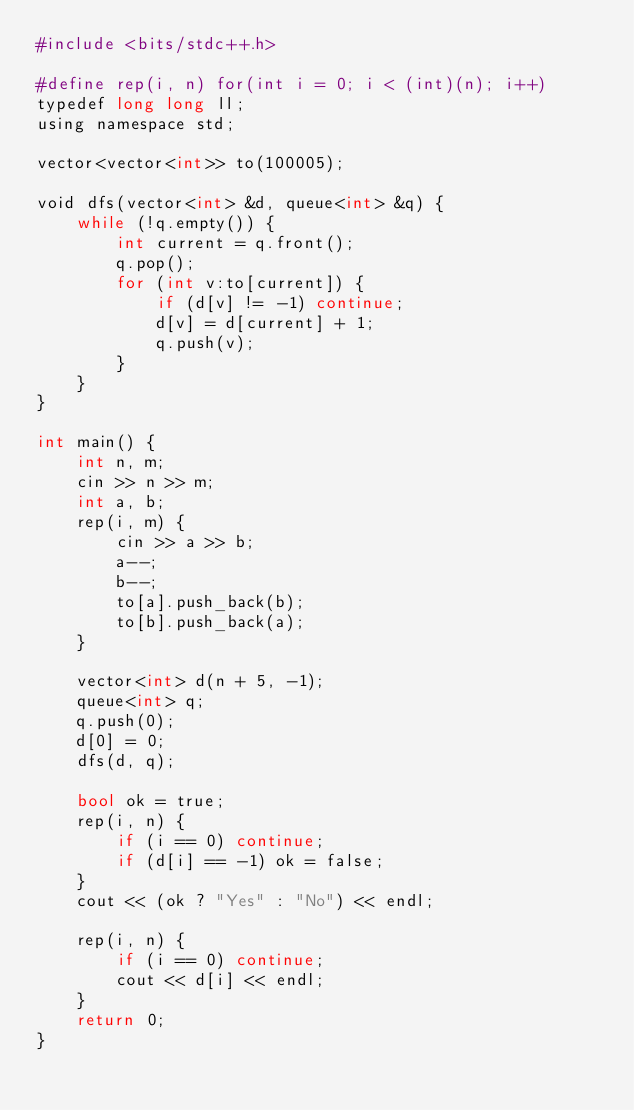Convert code to text. <code><loc_0><loc_0><loc_500><loc_500><_Python_>#include <bits/stdc++.h>

#define rep(i, n) for(int i = 0; i < (int)(n); i++)
typedef long long ll;
using namespace std;

vector<vector<int>> to(100005);

void dfs(vector<int> &d, queue<int> &q) {
    while (!q.empty()) {
        int current = q.front();
        q.pop();
        for (int v:to[current]) {
            if (d[v] != -1) continue;
            d[v] = d[current] + 1;
            q.push(v);
        }
    }
}

int main() {
    int n, m;
    cin >> n >> m;
    int a, b;
    rep(i, m) {
        cin >> a >> b;
        a--;
        b--;
        to[a].push_back(b);
        to[b].push_back(a);
    }

    vector<int> d(n + 5, -1);
    queue<int> q;
    q.push(0);
    d[0] = 0;
    dfs(d, q);

    bool ok = true;
    rep(i, n) {
        if (i == 0) continue;
        if (d[i] == -1) ok = false;
    }
    cout << (ok ? "Yes" : "No") << endl;

    rep(i, n) {
        if (i == 0) continue;
        cout << d[i] << endl;
    }
    return 0;
}</code> 